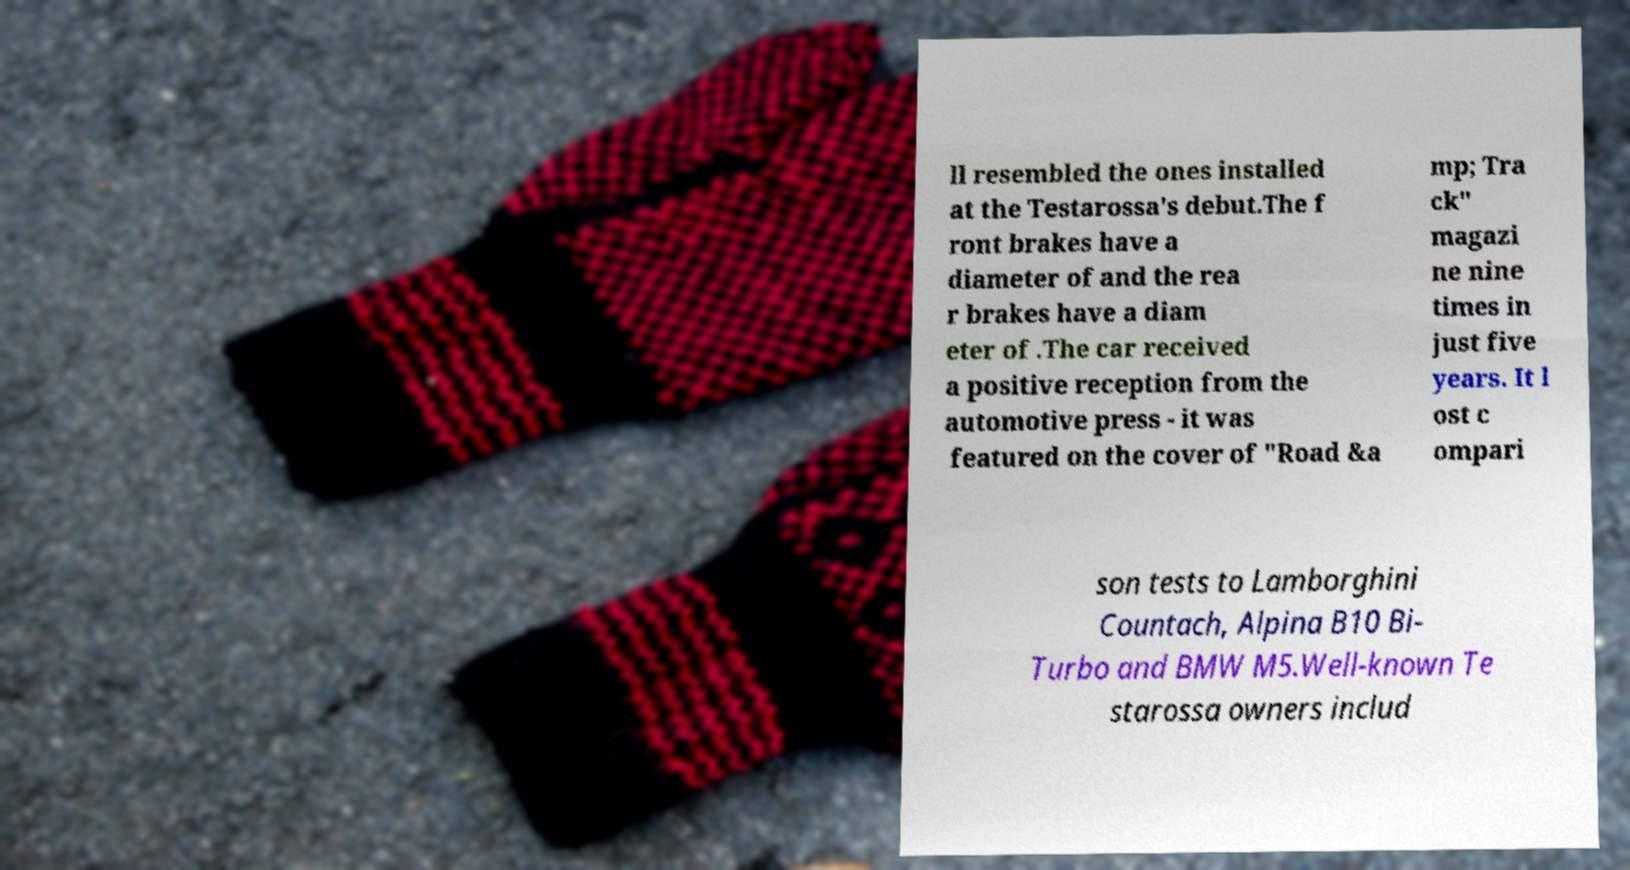Please read and relay the text visible in this image. What does it say? ll resembled the ones installed at the Testarossa's debut.The f ront brakes have a diameter of and the rea r brakes have a diam eter of .The car received a positive reception from the automotive press - it was featured on the cover of "Road &a mp; Tra ck" magazi ne nine times in just five years. It l ost c ompari son tests to Lamborghini Countach, Alpina B10 Bi- Turbo and BMW M5.Well-known Te starossa owners includ 